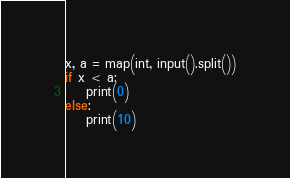<code> <loc_0><loc_0><loc_500><loc_500><_Python_>x, a = map(int, input().split())
if x < a:
    print(0)
else:
    print(10)</code> 